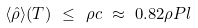Convert formula to latex. <formula><loc_0><loc_0><loc_500><loc_500>\langle \hat { \rho } \rangle ( T ) \ \leq \ \rho c \ \approx \ 0 . 8 2 \rho P l</formula> 